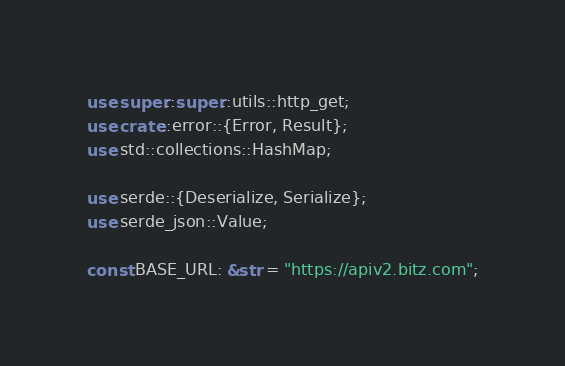Convert code to text. <code><loc_0><loc_0><loc_500><loc_500><_Rust_>use super::super::utils::http_get;
use crate::error::{Error, Result};
use std::collections::HashMap;

use serde::{Deserialize, Serialize};
use serde_json::Value;

const BASE_URL: &str = "https://apiv2.bitz.com";
</code> 